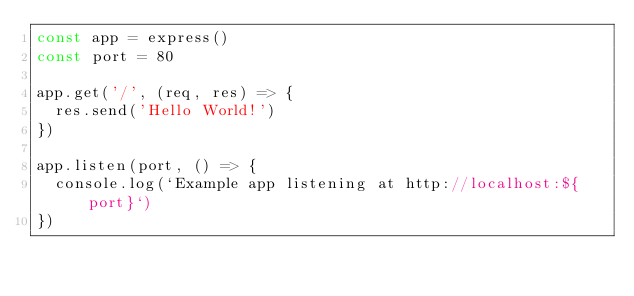Convert code to text. <code><loc_0><loc_0><loc_500><loc_500><_JavaScript_>const app = express()
const port = 80

app.get('/', (req, res) => {
  res.send('Hello World!')
})

app.listen(port, () => {
  console.log(`Example app listening at http://localhost:${port}`)
})</code> 